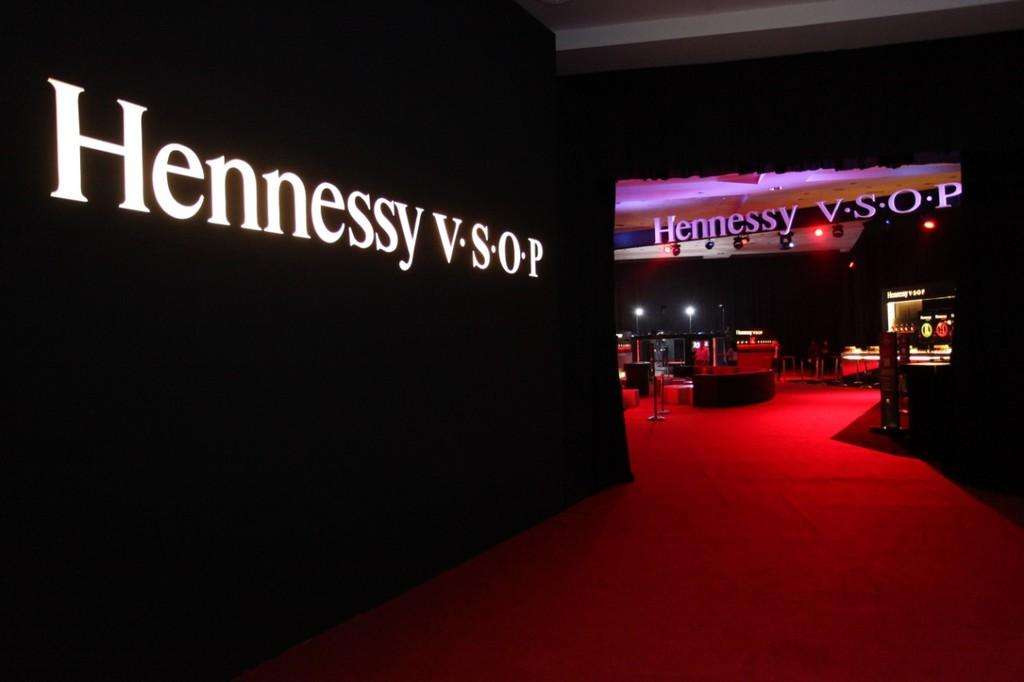What is the color of the carpet in the image? The carpet in the image is red. What can be seen illuminating the area in the image? There are lights in the image. What structures are present in the image? There are poles in the image. What is written on the banner in the image? There is a black banner with text in the image. What type of objects are present in the image? There are objects in the image. How would you describe the overall lighting in the image? The background of the image is dark. How many cans are visible on the red carpet in the image? There is no mention of cans in the image; the focus is on the red carpet, lights, poles, black banner, objects, and dark background. What is the head doing in the image? There is no mention of a head or any person in the image; it primarily features a red carpet, lights, poles, a black banner, objects, and a dark background. 